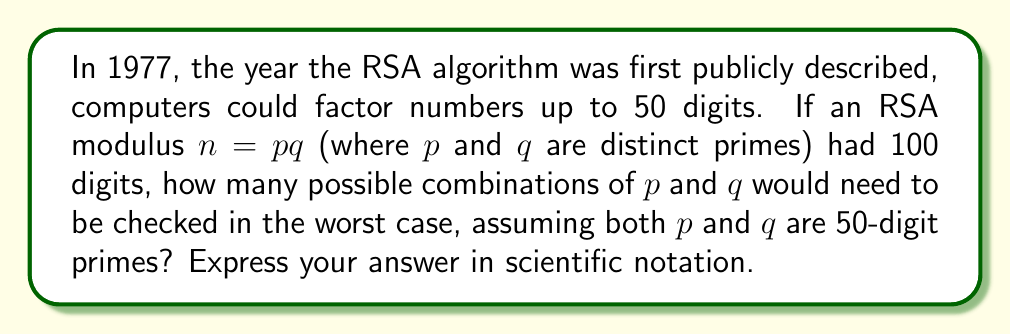Can you solve this math problem? Let's approach this step-by-step:

1) In RSA, the modulus $n$ is the product of two distinct primes $p$ and $q$.

2) We're told that $n$ has 100 digits, and both $p$ and $q$ are 50-digit primes.

3) The number of 50-digit numbers is:
   $$ 9 \times 10^{49} \text{ to } 10^{50} - 1 $$

4) However, we're only interested in prime numbers. The Prime Number Theorem gives us an estimate of the number of primes less than or equal to $x$:
   $$ \pi(x) \approx \frac{x}{\ln(x)} $$

5) For 50-digit numbers, $x = 10^{50}$. So the number of 50-digit primes is approximately:
   $$ \frac{10^{50}}{\ln(10^{50})} - \frac{9 \times 10^{49}}{\ln(9 \times 10^{49})} \approx 1.33 \times 10^{48} $$

6) If we had to check every possible combination of two 50-digit primes, we'd need to check:
   $$ (1.33 \times 10^{48})^2 = 1.77 \times 10^{96} $$

7) However, since $p$ and $q$ are distinct, we don't need to check combinations where $p = q$. This reduces our count by $1.33 \times 10^{48}$.

8) Also, since multiplication is commutative ($pq = qp$), we only need to check half of the remaining combinations.

9) Therefore, the total number of combinations to check is:
   $$ \frac{(1.33 \times 10^{48})^2 - 1.33 \times 10^{48}}{2} \approx 8.84 \times 10^{95} $$
Answer: $8.84 \times 10^{95}$ 